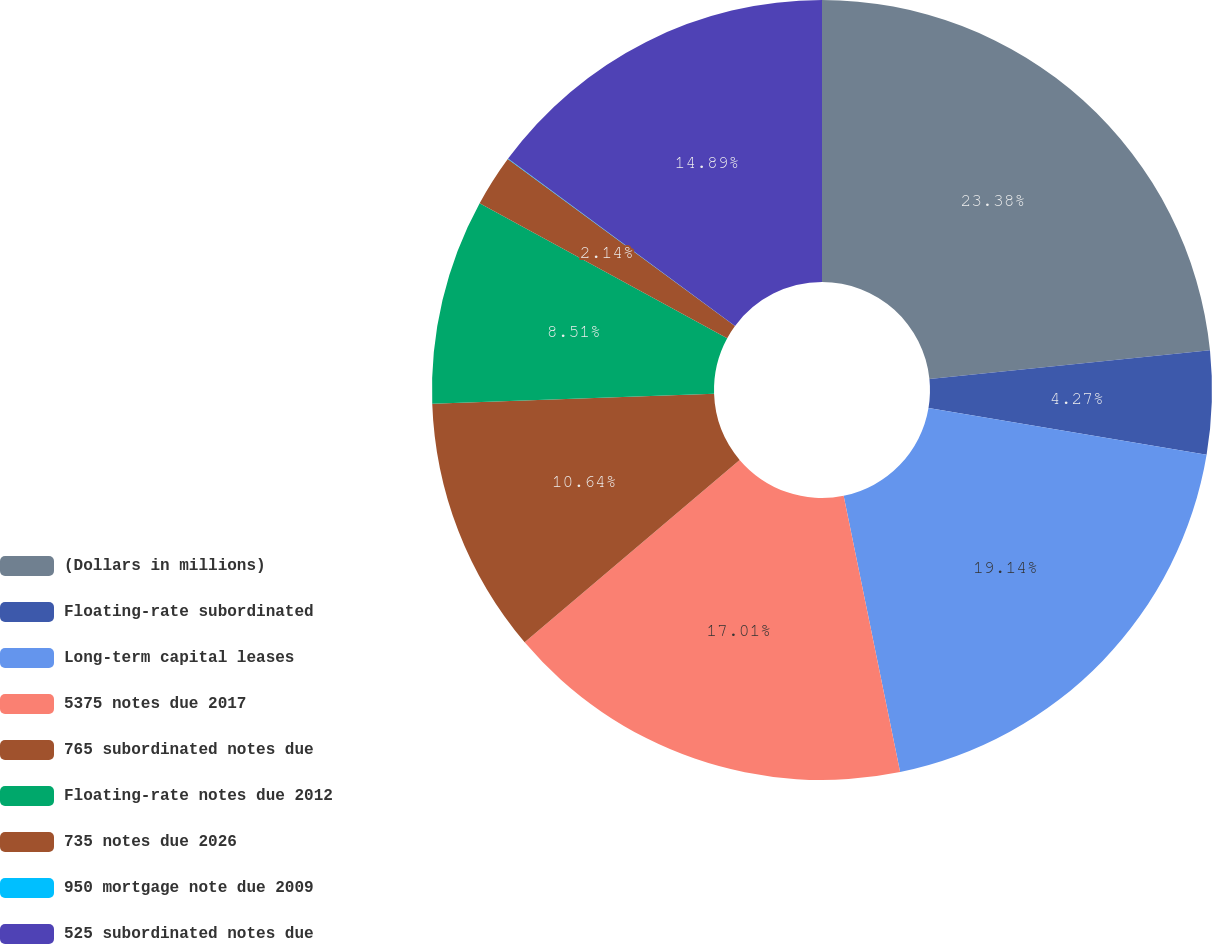<chart> <loc_0><loc_0><loc_500><loc_500><pie_chart><fcel>(Dollars in millions)<fcel>Floating-rate subordinated<fcel>Long-term capital leases<fcel>5375 notes due 2017<fcel>765 subordinated notes due<fcel>Floating-rate notes due 2012<fcel>735 notes due 2026<fcel>950 mortgage note due 2009<fcel>525 subordinated notes due<nl><fcel>23.38%<fcel>4.27%<fcel>19.14%<fcel>17.01%<fcel>10.64%<fcel>8.51%<fcel>2.14%<fcel>0.02%<fcel>14.89%<nl></chart> 